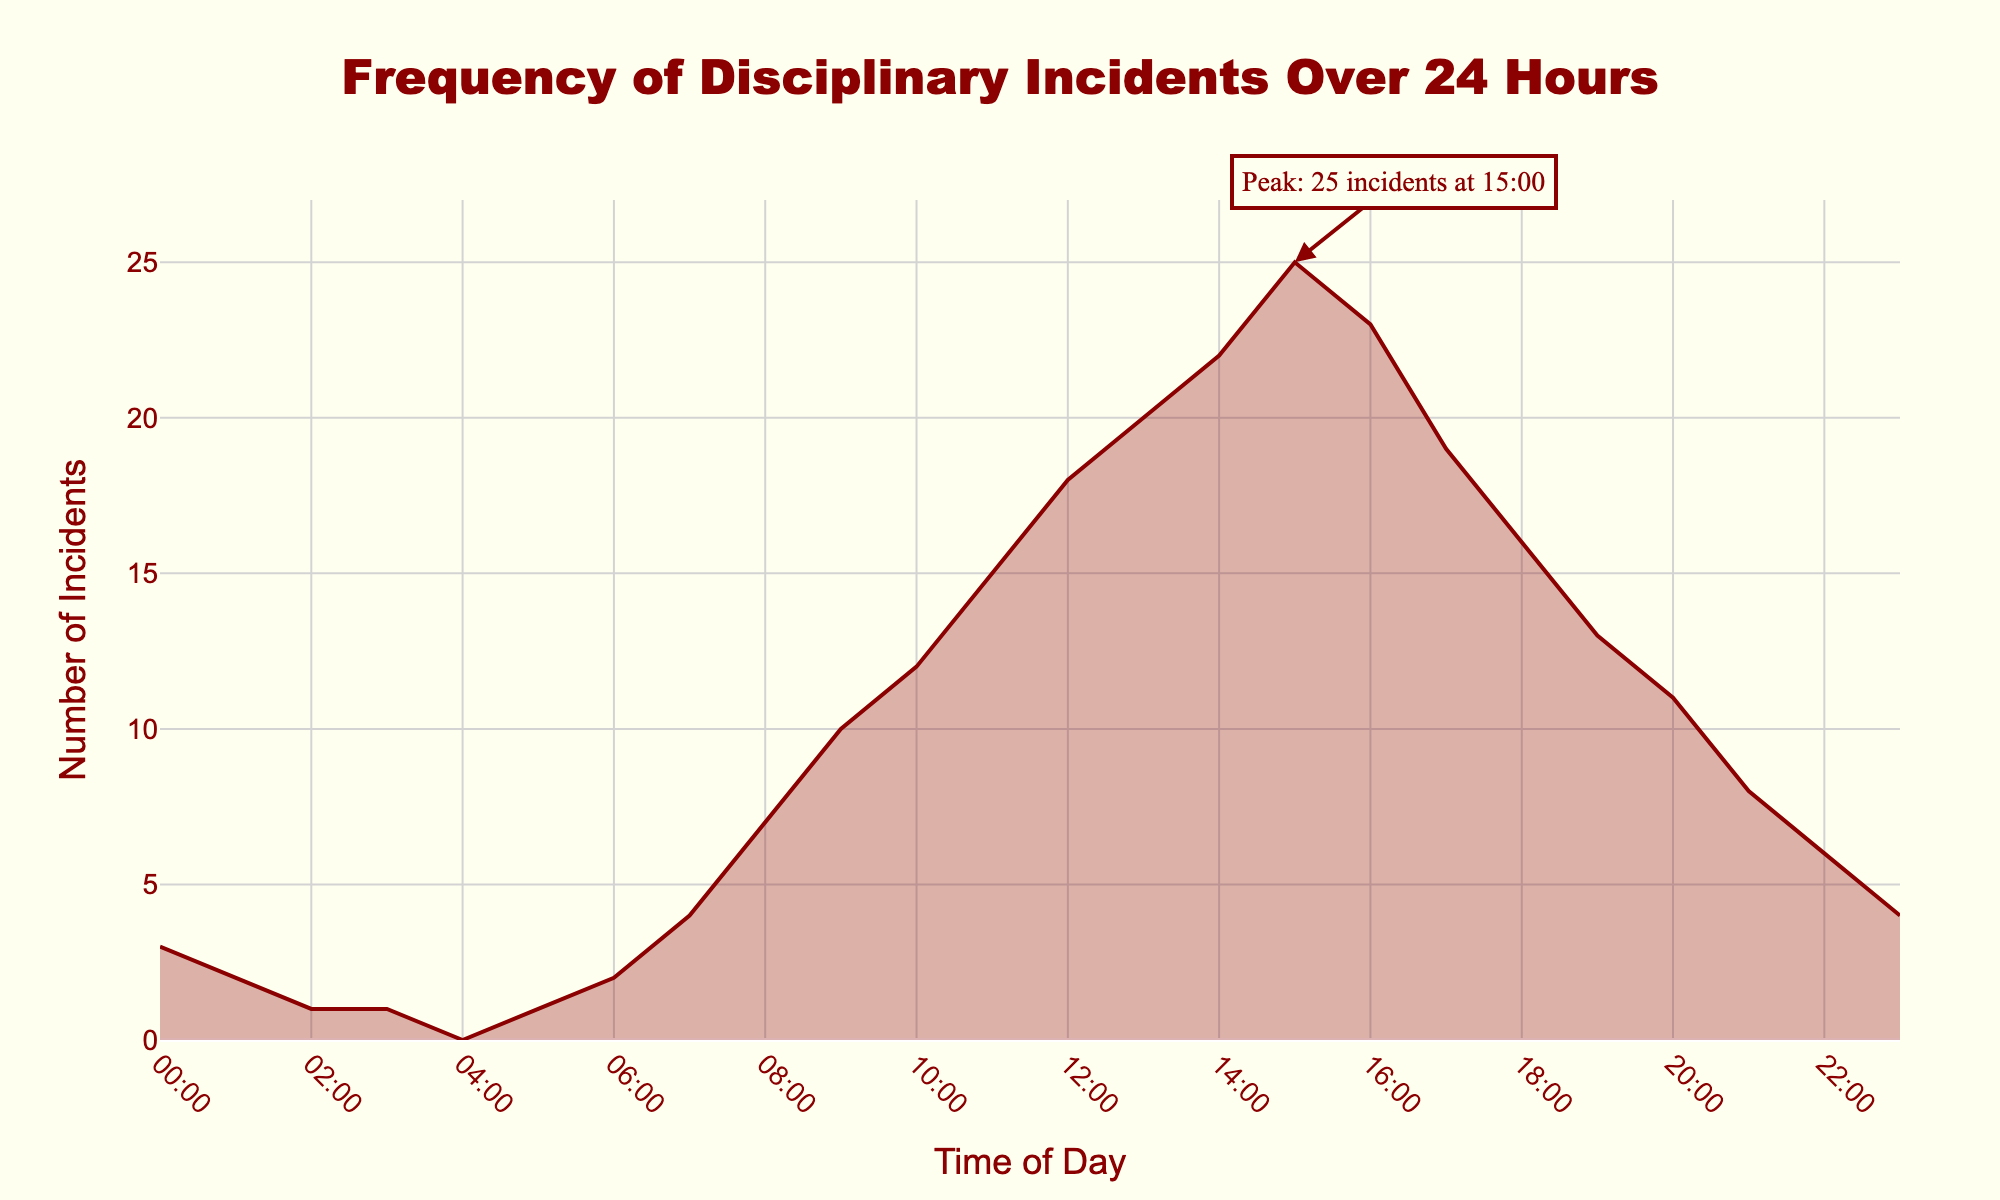What is the title of the plot? The title is usually located at the top of the figure, and in this case, it reads "Frequency of Disciplinary Incidents Over 24 Hours."
Answer: Frequency of Disciplinary Incidents Over 24 Hours What are the units on the x-axis? The x-axis shows the time of day in a 24-hour format, ranging from 00:00 to 23:00.
Answer: Time of Day (00:00 - 23:00) What is the peak time for disciplinary incidents? The peak time is annotated with an arrow and a note indicating "Peak: 25 incidents at 15:00."
Answer: 15:00 How many incidents occurred at 12:00? Look at the point on the plot where the time is 12:00 and check the corresponding y-value; the plot shows 18 incidents.
Answer: 18 What is the trend of incidents from 10:00 to 13:00? From 10:00 to 13:00, the number of incidents is increasing as seen by the upward slope in the curve.
Answer: Increasing What was the incident count at 19:00, and how does it compare to the count at 20:00? Look at the points for 19:00 (13 incidents) and 20:00 (11 incidents); compare the counts. 13 is greater than 11.
Answer: 19:00 had 13 incidents and 20:00 had 11 incidents; 19:00 had more incidents What is the general pattern of incidents between midnight and 06:00? From 00:00 to 06:00, the trend is relatively flat with low incident counts, as indicated by the near-horizontal sections of the plot.
Answer: Relatively flat with low counts How many total incidents occurred between 12:00 and 18:00? Sum the incident counts within this time range: 18 (12:00) + 20 (13:00) + 22 (14:00) + 25 (15:00) + 23 (16:00) + 19 (17:00) + 16 (18:00) = 143.
Answer: 143 What time of day has the least number of incidents? The least number of incidents (0) is at 04:00, as seen where the plot touches the x-axis.
Answer: 04:00 